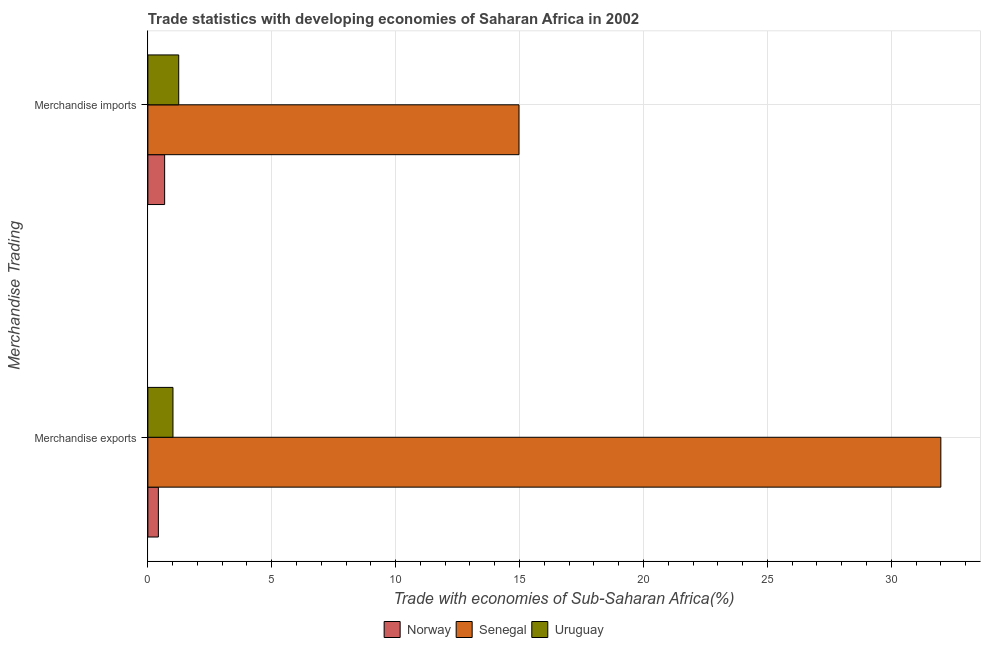Are the number of bars on each tick of the Y-axis equal?
Offer a terse response. Yes. What is the label of the 2nd group of bars from the top?
Your response must be concise. Merchandise exports. What is the merchandise exports in Senegal?
Provide a short and direct response. 32. Across all countries, what is the maximum merchandise imports?
Provide a short and direct response. 14.98. Across all countries, what is the minimum merchandise imports?
Make the answer very short. 0.68. In which country was the merchandise imports maximum?
Give a very brief answer. Senegal. What is the total merchandise exports in the graph?
Your response must be concise. 33.44. What is the difference between the merchandise exports in Norway and that in Senegal?
Offer a very short reply. -31.58. What is the difference between the merchandise exports in Norway and the merchandise imports in Senegal?
Keep it short and to the point. -14.55. What is the average merchandise imports per country?
Make the answer very short. 5.63. What is the difference between the merchandise imports and merchandise exports in Senegal?
Give a very brief answer. -17.03. In how many countries, is the merchandise imports greater than 26 %?
Offer a very short reply. 0. What is the ratio of the merchandise imports in Senegal to that in Uruguay?
Your answer should be very brief. 12.03. What does the 2nd bar from the top in Merchandise imports represents?
Give a very brief answer. Senegal. What does the 3rd bar from the bottom in Merchandise exports represents?
Your answer should be very brief. Uruguay. How many bars are there?
Your answer should be compact. 6. How many countries are there in the graph?
Provide a short and direct response. 3. Where does the legend appear in the graph?
Offer a terse response. Bottom center. How many legend labels are there?
Offer a terse response. 3. What is the title of the graph?
Keep it short and to the point. Trade statistics with developing economies of Saharan Africa in 2002. What is the label or title of the X-axis?
Your answer should be compact. Trade with economies of Sub-Saharan Africa(%). What is the label or title of the Y-axis?
Offer a very short reply. Merchandise Trading. What is the Trade with economies of Sub-Saharan Africa(%) of Norway in Merchandise exports?
Provide a short and direct response. 0.42. What is the Trade with economies of Sub-Saharan Africa(%) of Senegal in Merchandise exports?
Keep it short and to the point. 32. What is the Trade with economies of Sub-Saharan Africa(%) in Uruguay in Merchandise exports?
Provide a succinct answer. 1.01. What is the Trade with economies of Sub-Saharan Africa(%) of Norway in Merchandise imports?
Make the answer very short. 0.68. What is the Trade with economies of Sub-Saharan Africa(%) of Senegal in Merchandise imports?
Offer a very short reply. 14.98. What is the Trade with economies of Sub-Saharan Africa(%) of Uruguay in Merchandise imports?
Make the answer very short. 1.25. Across all Merchandise Trading, what is the maximum Trade with economies of Sub-Saharan Africa(%) of Norway?
Provide a succinct answer. 0.68. Across all Merchandise Trading, what is the maximum Trade with economies of Sub-Saharan Africa(%) of Senegal?
Provide a short and direct response. 32. Across all Merchandise Trading, what is the maximum Trade with economies of Sub-Saharan Africa(%) of Uruguay?
Give a very brief answer. 1.25. Across all Merchandise Trading, what is the minimum Trade with economies of Sub-Saharan Africa(%) in Norway?
Offer a very short reply. 0.42. Across all Merchandise Trading, what is the minimum Trade with economies of Sub-Saharan Africa(%) of Senegal?
Your response must be concise. 14.98. Across all Merchandise Trading, what is the minimum Trade with economies of Sub-Saharan Africa(%) in Uruguay?
Give a very brief answer. 1.01. What is the total Trade with economies of Sub-Saharan Africa(%) in Norway in the graph?
Provide a short and direct response. 1.1. What is the total Trade with economies of Sub-Saharan Africa(%) in Senegal in the graph?
Your answer should be compact. 46.98. What is the total Trade with economies of Sub-Saharan Africa(%) of Uruguay in the graph?
Give a very brief answer. 2.26. What is the difference between the Trade with economies of Sub-Saharan Africa(%) in Norway in Merchandise exports and that in Merchandise imports?
Give a very brief answer. -0.25. What is the difference between the Trade with economies of Sub-Saharan Africa(%) in Senegal in Merchandise exports and that in Merchandise imports?
Ensure brevity in your answer.  17.03. What is the difference between the Trade with economies of Sub-Saharan Africa(%) in Uruguay in Merchandise exports and that in Merchandise imports?
Offer a terse response. -0.23. What is the difference between the Trade with economies of Sub-Saharan Africa(%) in Norway in Merchandise exports and the Trade with economies of Sub-Saharan Africa(%) in Senegal in Merchandise imports?
Make the answer very short. -14.55. What is the difference between the Trade with economies of Sub-Saharan Africa(%) in Norway in Merchandise exports and the Trade with economies of Sub-Saharan Africa(%) in Uruguay in Merchandise imports?
Your answer should be compact. -0.82. What is the difference between the Trade with economies of Sub-Saharan Africa(%) of Senegal in Merchandise exports and the Trade with economies of Sub-Saharan Africa(%) of Uruguay in Merchandise imports?
Offer a terse response. 30.76. What is the average Trade with economies of Sub-Saharan Africa(%) of Norway per Merchandise Trading?
Your response must be concise. 0.55. What is the average Trade with economies of Sub-Saharan Africa(%) of Senegal per Merchandise Trading?
Your answer should be very brief. 23.49. What is the average Trade with economies of Sub-Saharan Africa(%) of Uruguay per Merchandise Trading?
Give a very brief answer. 1.13. What is the difference between the Trade with economies of Sub-Saharan Africa(%) in Norway and Trade with economies of Sub-Saharan Africa(%) in Senegal in Merchandise exports?
Ensure brevity in your answer.  -31.58. What is the difference between the Trade with economies of Sub-Saharan Africa(%) in Norway and Trade with economies of Sub-Saharan Africa(%) in Uruguay in Merchandise exports?
Your answer should be very brief. -0.59. What is the difference between the Trade with economies of Sub-Saharan Africa(%) in Senegal and Trade with economies of Sub-Saharan Africa(%) in Uruguay in Merchandise exports?
Give a very brief answer. 30.99. What is the difference between the Trade with economies of Sub-Saharan Africa(%) of Norway and Trade with economies of Sub-Saharan Africa(%) of Senegal in Merchandise imports?
Offer a very short reply. -14.3. What is the difference between the Trade with economies of Sub-Saharan Africa(%) of Norway and Trade with economies of Sub-Saharan Africa(%) of Uruguay in Merchandise imports?
Give a very brief answer. -0.57. What is the difference between the Trade with economies of Sub-Saharan Africa(%) of Senegal and Trade with economies of Sub-Saharan Africa(%) of Uruguay in Merchandise imports?
Make the answer very short. 13.73. What is the ratio of the Trade with economies of Sub-Saharan Africa(%) of Norway in Merchandise exports to that in Merchandise imports?
Your answer should be very brief. 0.63. What is the ratio of the Trade with economies of Sub-Saharan Africa(%) of Senegal in Merchandise exports to that in Merchandise imports?
Keep it short and to the point. 2.14. What is the ratio of the Trade with economies of Sub-Saharan Africa(%) of Uruguay in Merchandise exports to that in Merchandise imports?
Your answer should be compact. 0.81. What is the difference between the highest and the second highest Trade with economies of Sub-Saharan Africa(%) of Norway?
Provide a short and direct response. 0.25. What is the difference between the highest and the second highest Trade with economies of Sub-Saharan Africa(%) in Senegal?
Offer a very short reply. 17.03. What is the difference between the highest and the second highest Trade with economies of Sub-Saharan Africa(%) in Uruguay?
Give a very brief answer. 0.23. What is the difference between the highest and the lowest Trade with economies of Sub-Saharan Africa(%) in Norway?
Provide a short and direct response. 0.25. What is the difference between the highest and the lowest Trade with economies of Sub-Saharan Africa(%) in Senegal?
Your response must be concise. 17.03. What is the difference between the highest and the lowest Trade with economies of Sub-Saharan Africa(%) of Uruguay?
Your answer should be very brief. 0.23. 